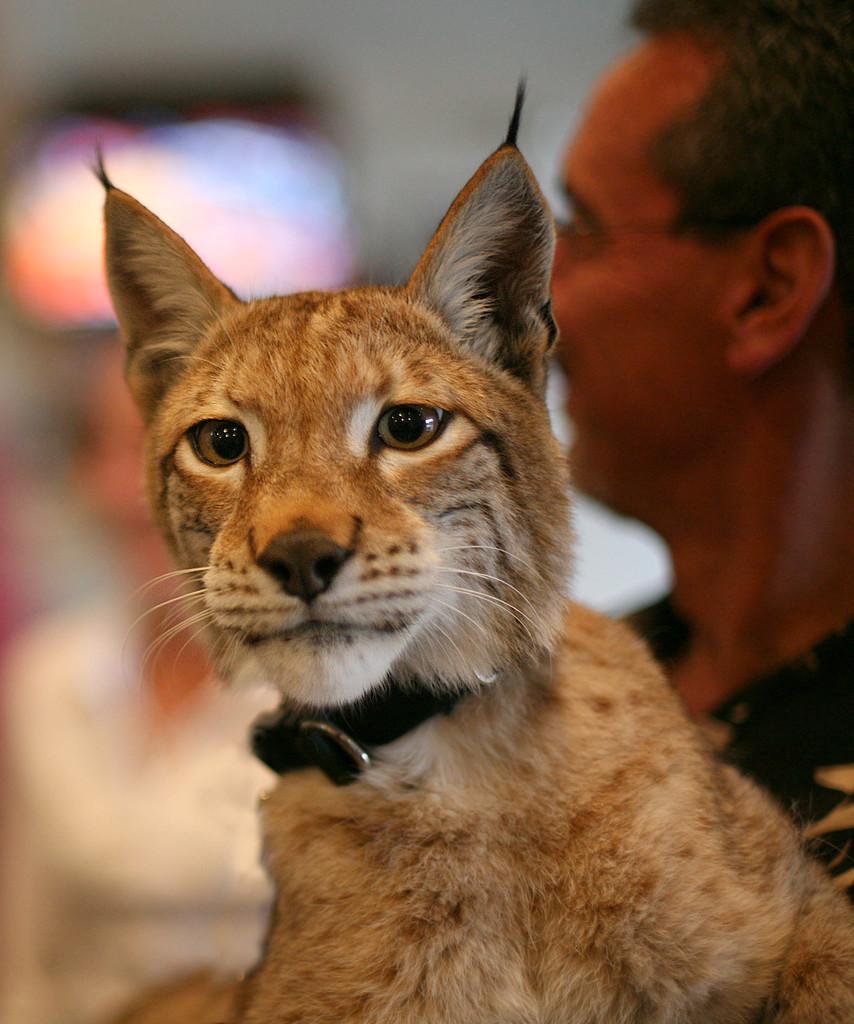Describe this image in one or two sentences. In this picture we can see a cat in the front, on the right side there is a man, there is another person in the background, we can see a blurry background. 